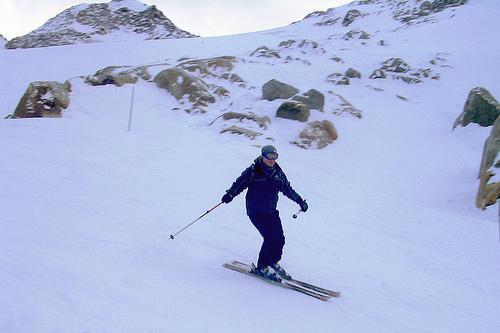How many people are in the image?
Give a very brief answer. 1. 